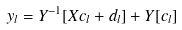<formula> <loc_0><loc_0><loc_500><loc_500>y _ { l } = Y ^ { - 1 } [ X c _ { l } + d _ { l } ] + Y [ c _ { l } ]</formula> 